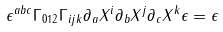Convert formula to latex. <formula><loc_0><loc_0><loc_500><loc_500>\epsilon ^ { a b c } \Gamma _ { 0 1 2 } \Gamma _ { i j k } \partial _ { a } X ^ { i } \partial _ { b } X ^ { j } \partial _ { c } X ^ { k } \epsilon = \epsilon</formula> 